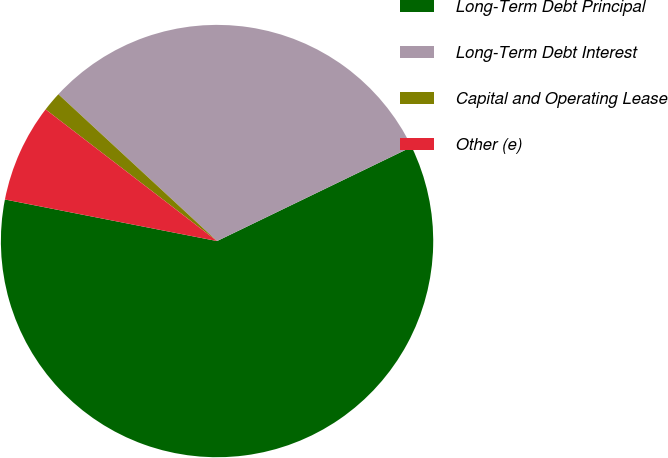Convert chart to OTSL. <chart><loc_0><loc_0><loc_500><loc_500><pie_chart><fcel>Long-Term Debt Principal<fcel>Long-Term Debt Interest<fcel>Capital and Operating Lease<fcel>Other (e)<nl><fcel>60.25%<fcel>30.95%<fcel>1.46%<fcel>7.34%<nl></chart> 